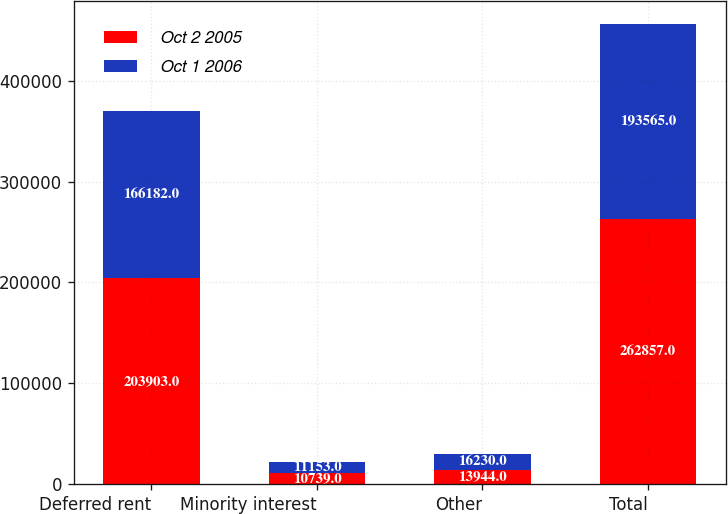Convert chart to OTSL. <chart><loc_0><loc_0><loc_500><loc_500><stacked_bar_chart><ecel><fcel>Deferred rent<fcel>Minority interest<fcel>Other<fcel>Total<nl><fcel>Oct 2 2005<fcel>203903<fcel>10739<fcel>13944<fcel>262857<nl><fcel>Oct 1 2006<fcel>166182<fcel>11153<fcel>16230<fcel>193565<nl></chart> 